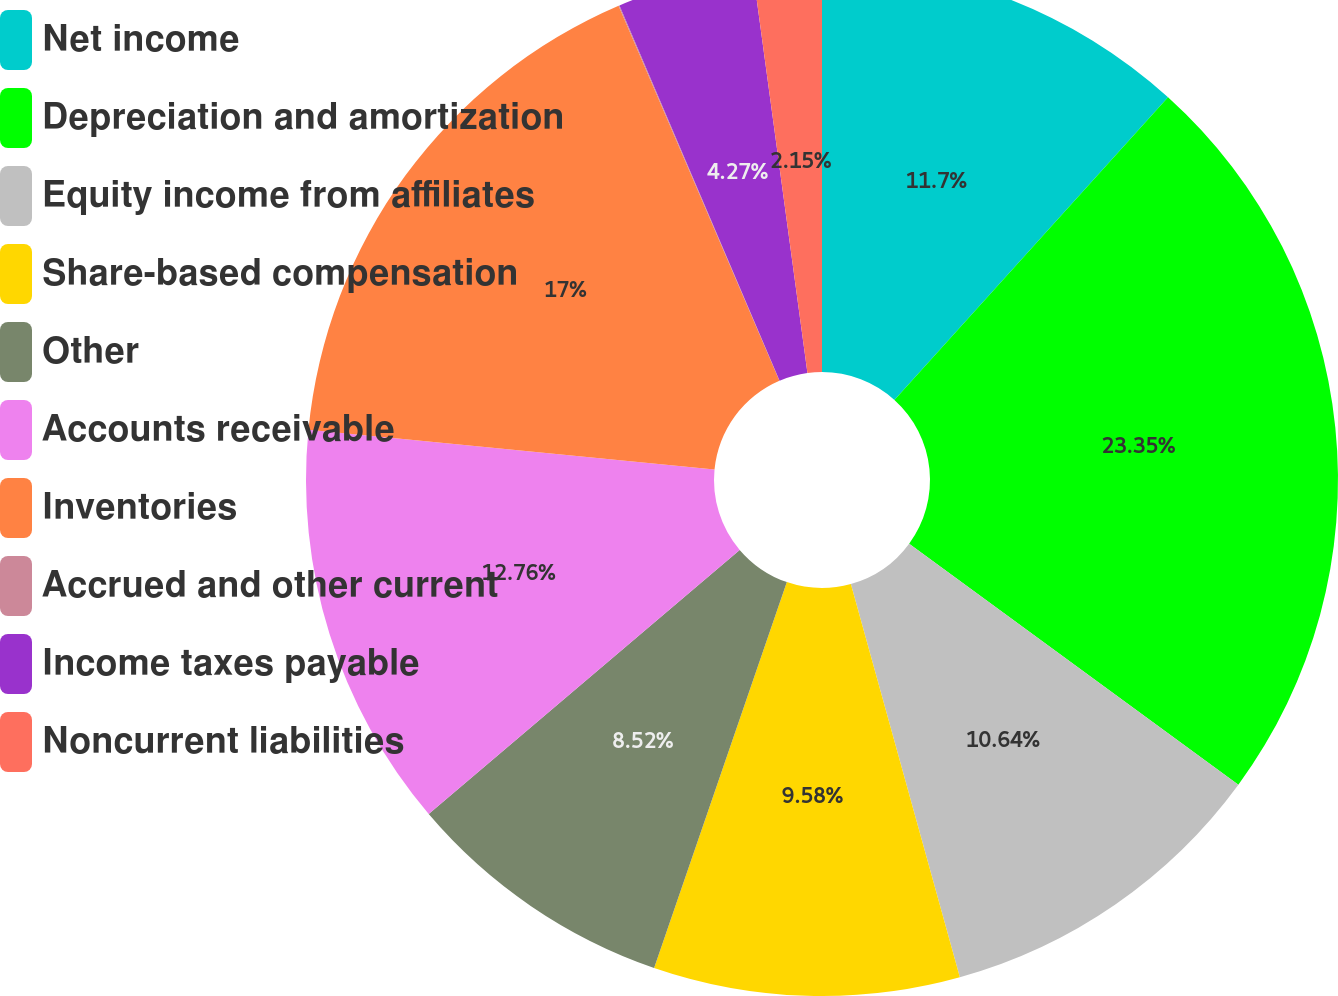Convert chart to OTSL. <chart><loc_0><loc_0><loc_500><loc_500><pie_chart><fcel>Net income<fcel>Depreciation and amortization<fcel>Equity income from affiliates<fcel>Share-based compensation<fcel>Other<fcel>Accounts receivable<fcel>Inventories<fcel>Accrued and other current<fcel>Income taxes payable<fcel>Noncurrent liabilities<nl><fcel>11.7%<fcel>23.36%<fcel>10.64%<fcel>9.58%<fcel>8.52%<fcel>12.76%<fcel>17.0%<fcel>0.03%<fcel>4.27%<fcel>2.15%<nl></chart> 